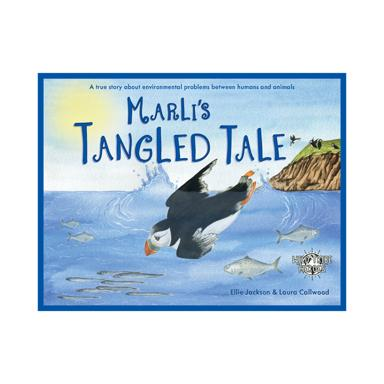Can you describe the environmental issue that 'Marli's Tangled Tale' addresses? 'Marli's Tangled Tale' tackles the pressing issue of ocean pollution and its impact on marine life. The story specifically focuses on the dangers of discarded fishing nets, highlighting the challenges faced by Marli, a little puffin, and how it navigates through these threats. 